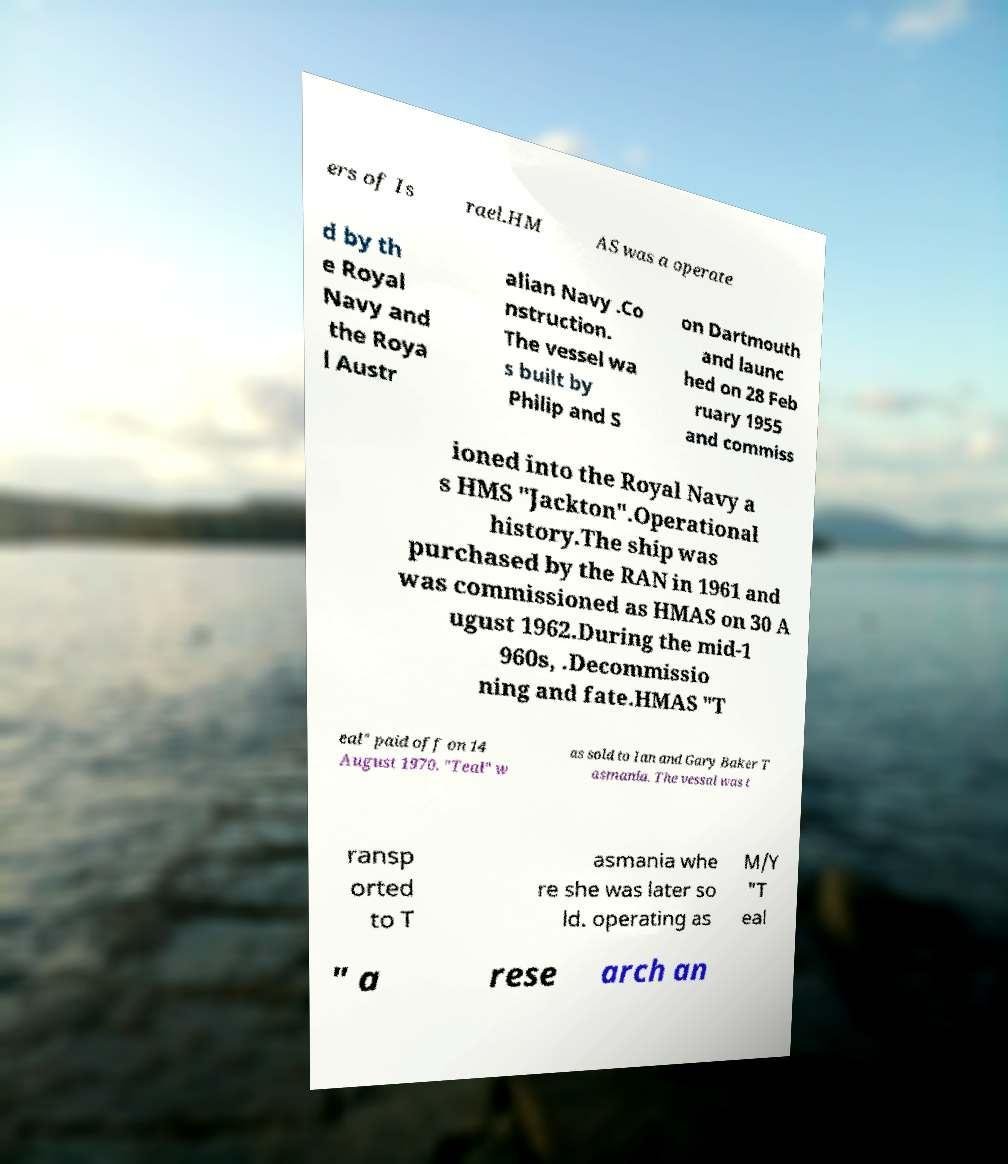Can you read and provide the text displayed in the image?This photo seems to have some interesting text. Can you extract and type it out for me? ers of Is rael.HM AS was a operate d by th e Royal Navy and the Roya l Austr alian Navy .Co nstruction. The vessel wa s built by Philip and S on Dartmouth and launc hed on 28 Feb ruary 1955 and commiss ioned into the Royal Navy a s HMS "Jackton".Operational history.The ship was purchased by the RAN in 1961 and was commissioned as HMAS on 30 A ugust 1962.During the mid-1 960s, .Decommissio ning and fate.HMAS "T eal" paid off on 14 August 1970. "Teal" w as sold to Ian and Gary Baker T asmania. The vessal was t ransp orted to T asmania whe re she was later so ld. operating as M/Y "T eal " a rese arch an 